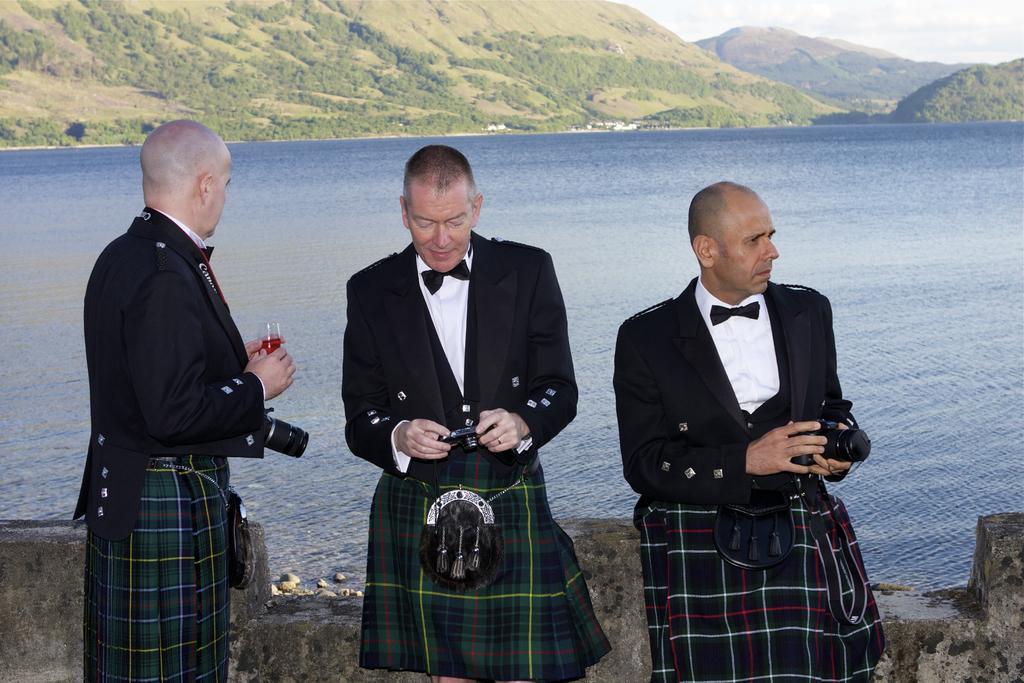Could you give a brief overview of what you see in this image? In this image we can see three people standing and holding the objects, there are some trees, stones, mountains and water, also we can see the sky with clouds. 